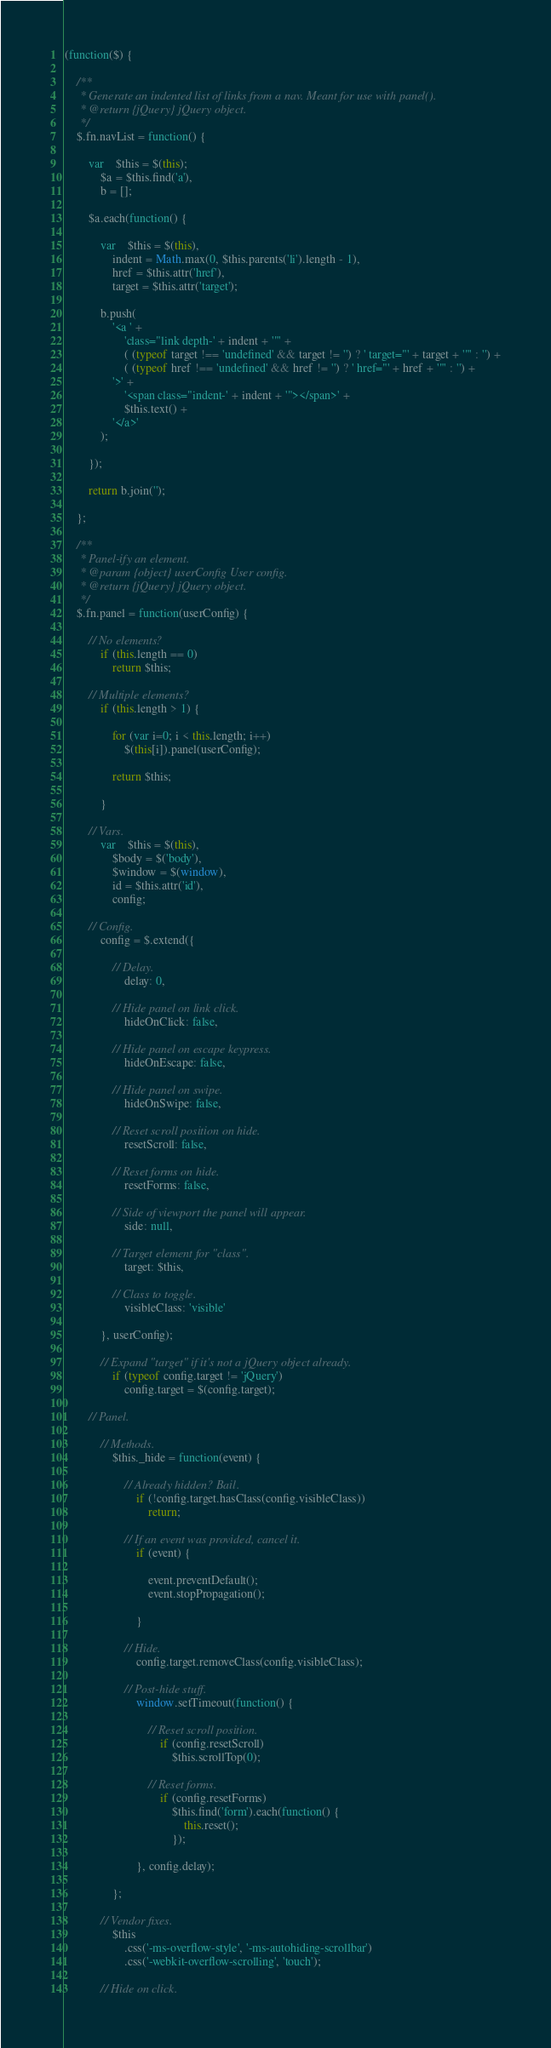<code> <loc_0><loc_0><loc_500><loc_500><_JavaScript_>(function($) {

	/**
	 * Generate an indented list of links from a nav. Meant for use with panel().
	 * @return {jQuery} jQuery object.
	 */
	$.fn.navList = function() {

		var	$this = $(this);
			$a = $this.find('a'),
			b = [];

		$a.each(function() {

			var	$this = $(this),
				indent = Math.max(0, $this.parents('li').length - 1),
				href = $this.attr('href'),
				target = $this.attr('target');

			b.push(
				'<a ' +
					'class="link depth-' + indent + '"' +
					( (typeof target !== 'undefined' && target != '') ? ' target="' + target + '"' : '') +
					( (typeof href !== 'undefined' && href != '') ? ' href="' + href + '"' : '') +
				'>' +
					'<span class="indent-' + indent + '"></span>' +
					$this.text() +
				'</a>'
			);

		});

		return b.join('');

	};

	/**
	 * Panel-ify an element.
	 * @param {object} userConfig User config.
	 * @return {jQuery} jQuery object.
	 */
	$.fn.panel = function(userConfig) {

		// No elements?
			if (this.length == 0)
				return $this;

		// Multiple elements?
			if (this.length > 1) {

				for (var i=0; i < this.length; i++)
					$(this[i]).panel(userConfig);

				return $this;

			}

		// Vars.
			var	$this = $(this),
				$body = $('body'),
				$window = $(window),
				id = $this.attr('id'),
				config;

		// Config.
			config = $.extend({

				// Delay.
					delay: 0,

				// Hide panel on link click.
					hideOnClick: false,

				// Hide panel on escape keypress.
					hideOnEscape: false,

				// Hide panel on swipe.
					hideOnSwipe: false,

				// Reset scroll position on hide.
					resetScroll: false,

				// Reset forms on hide.
					resetForms: false,

				// Side of viewport the panel will appear.
					side: null,

				// Target element for "class".
					target: $this,

				// Class to toggle.
					visibleClass: 'visible'

			}, userConfig);

			// Expand "target" if it's not a jQuery object already.
				if (typeof config.target != 'jQuery')
					config.target = $(config.target);

		// Panel.

			// Methods.
				$this._hide = function(event) {

					// Already hidden? Bail.
						if (!config.target.hasClass(config.visibleClass))
							return;

					// If an event was provided, cancel it.
						if (event) {

							event.preventDefault();
							event.stopPropagation();

						}

					// Hide.
						config.target.removeClass(config.visibleClass);

					// Post-hide stuff.
						window.setTimeout(function() {

							// Reset scroll position.
								if (config.resetScroll)
									$this.scrollTop(0);

							// Reset forms.
								if (config.resetForms)
									$this.find('form').each(function() {
										this.reset();
									});

						}, config.delay);

				};

			// Vendor fixes.
				$this
					.css('-ms-overflow-style', '-ms-autohiding-scrollbar')
					.css('-webkit-overflow-scrolling', 'touch');

			// Hide on click.</code> 